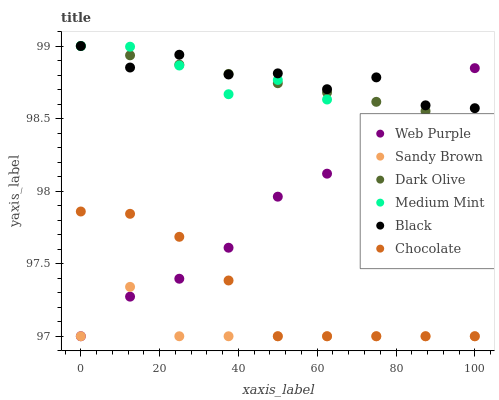Does Sandy Brown have the minimum area under the curve?
Answer yes or no. Yes. Does Black have the maximum area under the curve?
Answer yes or no. Yes. Does Dark Olive have the minimum area under the curve?
Answer yes or no. No. Does Dark Olive have the maximum area under the curve?
Answer yes or no. No. Is Dark Olive the smoothest?
Answer yes or no. Yes. Is Black the roughest?
Answer yes or no. Yes. Is Chocolate the smoothest?
Answer yes or no. No. Is Chocolate the roughest?
Answer yes or no. No. Does Chocolate have the lowest value?
Answer yes or no. Yes. Does Dark Olive have the lowest value?
Answer yes or no. No. Does Black have the highest value?
Answer yes or no. Yes. Does Chocolate have the highest value?
Answer yes or no. No. Is Sandy Brown less than Black?
Answer yes or no. Yes. Is Medium Mint greater than Sandy Brown?
Answer yes or no. Yes. Does Black intersect Dark Olive?
Answer yes or no. Yes. Is Black less than Dark Olive?
Answer yes or no. No. Is Black greater than Dark Olive?
Answer yes or no. No. Does Sandy Brown intersect Black?
Answer yes or no. No. 